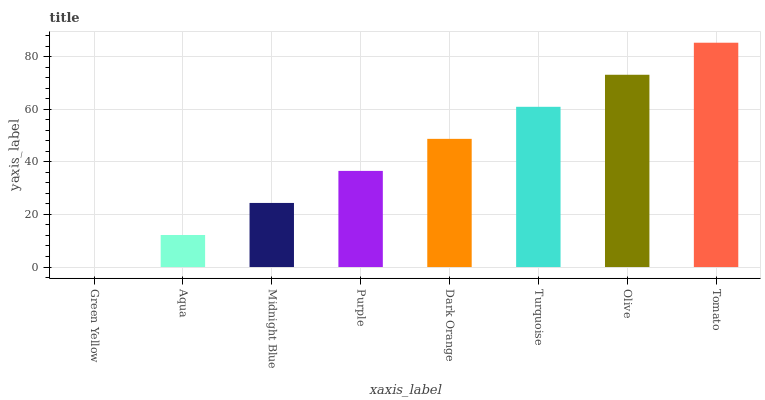Is Aqua the minimum?
Answer yes or no. No. Is Aqua the maximum?
Answer yes or no. No. Is Aqua greater than Green Yellow?
Answer yes or no. Yes. Is Green Yellow less than Aqua?
Answer yes or no. Yes. Is Green Yellow greater than Aqua?
Answer yes or no. No. Is Aqua less than Green Yellow?
Answer yes or no. No. Is Dark Orange the high median?
Answer yes or no. Yes. Is Purple the low median?
Answer yes or no. Yes. Is Turquoise the high median?
Answer yes or no. No. Is Olive the low median?
Answer yes or no. No. 